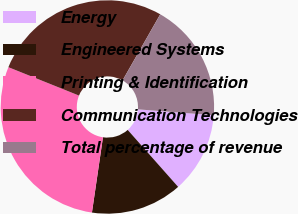Convert chart to OTSL. <chart><loc_0><loc_0><loc_500><loc_500><pie_chart><fcel>Energy<fcel>Engineered Systems<fcel>Printing & Identification<fcel>Communication Technologies<fcel>Total percentage of revenue<nl><fcel>12.24%<fcel>13.85%<fcel>28.77%<fcel>27.16%<fcel>17.98%<nl></chart> 